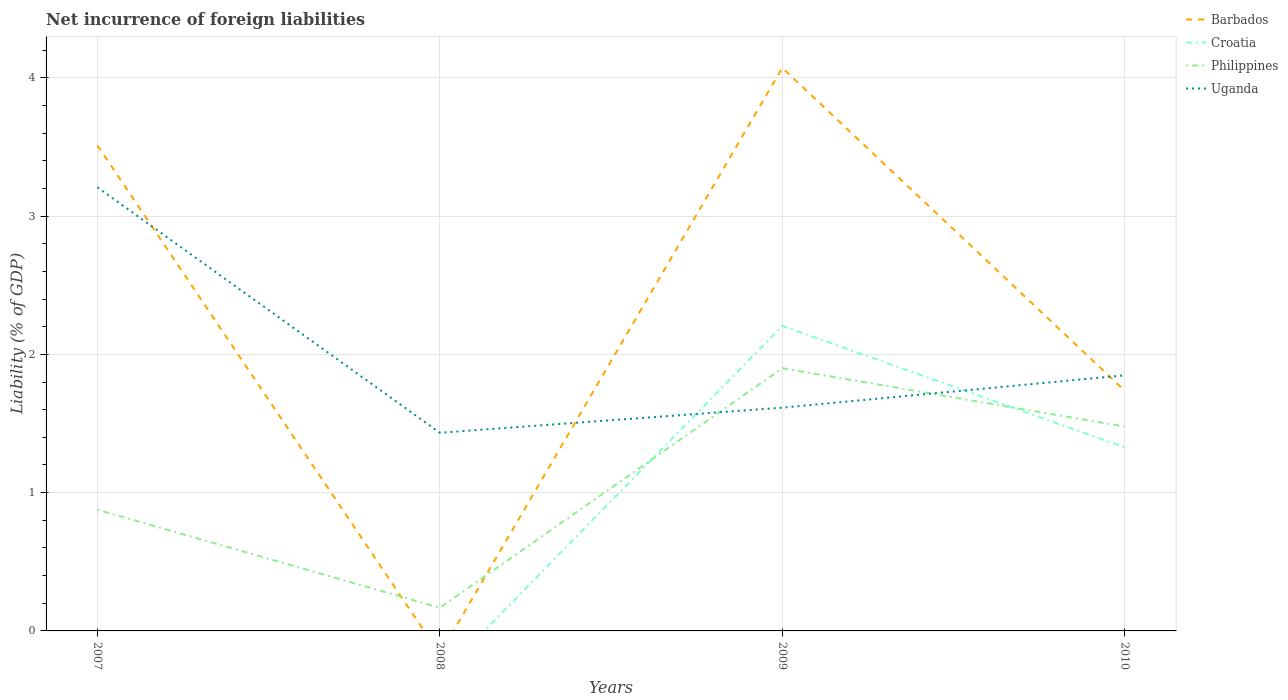How many different coloured lines are there?
Keep it short and to the point. 4. Does the line corresponding to Barbados intersect with the line corresponding to Uganda?
Give a very brief answer. Yes. Is the number of lines equal to the number of legend labels?
Keep it short and to the point. No. Across all years, what is the maximum net incurrence of foreign liabilities in Philippines?
Your answer should be compact. 0.17. What is the total net incurrence of foreign liabilities in Philippines in the graph?
Provide a short and direct response. -0.6. What is the difference between the highest and the second highest net incurrence of foreign liabilities in Uganda?
Keep it short and to the point. 1.78. How many years are there in the graph?
Offer a very short reply. 4. What is the difference between two consecutive major ticks on the Y-axis?
Provide a short and direct response. 1. How many legend labels are there?
Offer a very short reply. 4. What is the title of the graph?
Make the answer very short. Net incurrence of foreign liabilities. What is the label or title of the Y-axis?
Your response must be concise. Liability (% of GDP). What is the Liability (% of GDP) in Barbados in 2007?
Provide a short and direct response. 3.51. What is the Liability (% of GDP) in Croatia in 2007?
Your answer should be compact. 0. What is the Liability (% of GDP) of Philippines in 2007?
Your response must be concise. 0.88. What is the Liability (% of GDP) of Uganda in 2007?
Provide a succinct answer. 3.21. What is the Liability (% of GDP) of Barbados in 2008?
Offer a very short reply. 0. What is the Liability (% of GDP) in Philippines in 2008?
Offer a terse response. 0.17. What is the Liability (% of GDP) of Uganda in 2008?
Ensure brevity in your answer.  1.43. What is the Liability (% of GDP) in Barbados in 2009?
Provide a short and direct response. 4.07. What is the Liability (% of GDP) in Croatia in 2009?
Give a very brief answer. 2.21. What is the Liability (% of GDP) in Philippines in 2009?
Ensure brevity in your answer.  1.9. What is the Liability (% of GDP) of Uganda in 2009?
Your response must be concise. 1.61. What is the Liability (% of GDP) of Barbados in 2010?
Offer a very short reply. 1.74. What is the Liability (% of GDP) of Croatia in 2010?
Your response must be concise. 1.33. What is the Liability (% of GDP) of Philippines in 2010?
Keep it short and to the point. 1.48. What is the Liability (% of GDP) of Uganda in 2010?
Your response must be concise. 1.85. Across all years, what is the maximum Liability (% of GDP) of Barbados?
Make the answer very short. 4.07. Across all years, what is the maximum Liability (% of GDP) in Croatia?
Make the answer very short. 2.21. Across all years, what is the maximum Liability (% of GDP) of Philippines?
Keep it short and to the point. 1.9. Across all years, what is the maximum Liability (% of GDP) in Uganda?
Your answer should be very brief. 3.21. Across all years, what is the minimum Liability (% of GDP) in Barbados?
Ensure brevity in your answer.  0. Across all years, what is the minimum Liability (% of GDP) of Croatia?
Your response must be concise. 0. Across all years, what is the minimum Liability (% of GDP) of Philippines?
Your answer should be very brief. 0.17. Across all years, what is the minimum Liability (% of GDP) of Uganda?
Your answer should be compact. 1.43. What is the total Liability (% of GDP) in Barbados in the graph?
Give a very brief answer. 9.32. What is the total Liability (% of GDP) of Croatia in the graph?
Offer a terse response. 3.53. What is the total Liability (% of GDP) of Philippines in the graph?
Your answer should be compact. 4.42. What is the total Liability (% of GDP) in Uganda in the graph?
Offer a very short reply. 8.1. What is the difference between the Liability (% of GDP) of Philippines in 2007 and that in 2008?
Your answer should be very brief. 0.71. What is the difference between the Liability (% of GDP) in Uganda in 2007 and that in 2008?
Keep it short and to the point. 1.78. What is the difference between the Liability (% of GDP) in Barbados in 2007 and that in 2009?
Keep it short and to the point. -0.56. What is the difference between the Liability (% of GDP) in Philippines in 2007 and that in 2009?
Make the answer very short. -1.02. What is the difference between the Liability (% of GDP) of Uganda in 2007 and that in 2009?
Keep it short and to the point. 1.59. What is the difference between the Liability (% of GDP) in Barbados in 2007 and that in 2010?
Your answer should be very brief. 1.77. What is the difference between the Liability (% of GDP) in Philippines in 2007 and that in 2010?
Provide a short and direct response. -0.6. What is the difference between the Liability (% of GDP) of Uganda in 2007 and that in 2010?
Offer a terse response. 1.36. What is the difference between the Liability (% of GDP) in Philippines in 2008 and that in 2009?
Provide a succinct answer. -1.73. What is the difference between the Liability (% of GDP) of Uganda in 2008 and that in 2009?
Ensure brevity in your answer.  -0.18. What is the difference between the Liability (% of GDP) of Philippines in 2008 and that in 2010?
Offer a terse response. -1.31. What is the difference between the Liability (% of GDP) in Uganda in 2008 and that in 2010?
Provide a short and direct response. -0.42. What is the difference between the Liability (% of GDP) in Barbados in 2009 and that in 2010?
Offer a very short reply. 2.33. What is the difference between the Liability (% of GDP) of Croatia in 2009 and that in 2010?
Your answer should be very brief. 0.88. What is the difference between the Liability (% of GDP) in Philippines in 2009 and that in 2010?
Keep it short and to the point. 0.42. What is the difference between the Liability (% of GDP) in Uganda in 2009 and that in 2010?
Make the answer very short. -0.23. What is the difference between the Liability (% of GDP) in Barbados in 2007 and the Liability (% of GDP) in Philippines in 2008?
Make the answer very short. 3.34. What is the difference between the Liability (% of GDP) in Barbados in 2007 and the Liability (% of GDP) in Uganda in 2008?
Provide a short and direct response. 2.08. What is the difference between the Liability (% of GDP) in Philippines in 2007 and the Liability (% of GDP) in Uganda in 2008?
Ensure brevity in your answer.  -0.56. What is the difference between the Liability (% of GDP) in Barbados in 2007 and the Liability (% of GDP) in Croatia in 2009?
Your response must be concise. 1.31. What is the difference between the Liability (% of GDP) of Barbados in 2007 and the Liability (% of GDP) of Philippines in 2009?
Make the answer very short. 1.61. What is the difference between the Liability (% of GDP) in Barbados in 2007 and the Liability (% of GDP) in Uganda in 2009?
Ensure brevity in your answer.  1.9. What is the difference between the Liability (% of GDP) of Philippines in 2007 and the Liability (% of GDP) of Uganda in 2009?
Ensure brevity in your answer.  -0.74. What is the difference between the Liability (% of GDP) of Barbados in 2007 and the Liability (% of GDP) of Croatia in 2010?
Ensure brevity in your answer.  2.18. What is the difference between the Liability (% of GDP) in Barbados in 2007 and the Liability (% of GDP) in Philippines in 2010?
Ensure brevity in your answer.  2.03. What is the difference between the Liability (% of GDP) in Barbados in 2007 and the Liability (% of GDP) in Uganda in 2010?
Your response must be concise. 1.66. What is the difference between the Liability (% of GDP) in Philippines in 2007 and the Liability (% of GDP) in Uganda in 2010?
Offer a very short reply. -0.97. What is the difference between the Liability (% of GDP) in Philippines in 2008 and the Liability (% of GDP) in Uganda in 2009?
Make the answer very short. -1.45. What is the difference between the Liability (% of GDP) of Philippines in 2008 and the Liability (% of GDP) of Uganda in 2010?
Offer a very short reply. -1.68. What is the difference between the Liability (% of GDP) in Barbados in 2009 and the Liability (% of GDP) in Croatia in 2010?
Provide a short and direct response. 2.74. What is the difference between the Liability (% of GDP) of Barbados in 2009 and the Liability (% of GDP) of Philippines in 2010?
Offer a terse response. 2.59. What is the difference between the Liability (% of GDP) of Barbados in 2009 and the Liability (% of GDP) of Uganda in 2010?
Offer a very short reply. 2.22. What is the difference between the Liability (% of GDP) of Croatia in 2009 and the Liability (% of GDP) of Philippines in 2010?
Provide a succinct answer. 0.73. What is the difference between the Liability (% of GDP) of Croatia in 2009 and the Liability (% of GDP) of Uganda in 2010?
Ensure brevity in your answer.  0.36. What is the difference between the Liability (% of GDP) in Philippines in 2009 and the Liability (% of GDP) in Uganda in 2010?
Keep it short and to the point. 0.05. What is the average Liability (% of GDP) of Barbados per year?
Your answer should be very brief. 2.33. What is the average Liability (% of GDP) of Croatia per year?
Your answer should be compact. 0.88. What is the average Liability (% of GDP) in Philippines per year?
Make the answer very short. 1.11. What is the average Liability (% of GDP) of Uganda per year?
Offer a very short reply. 2.03. In the year 2007, what is the difference between the Liability (% of GDP) in Barbados and Liability (% of GDP) in Philippines?
Keep it short and to the point. 2.63. In the year 2007, what is the difference between the Liability (% of GDP) of Barbados and Liability (% of GDP) of Uganda?
Give a very brief answer. 0.3. In the year 2007, what is the difference between the Liability (% of GDP) of Philippines and Liability (% of GDP) of Uganda?
Offer a very short reply. -2.33. In the year 2008, what is the difference between the Liability (% of GDP) in Philippines and Liability (% of GDP) in Uganda?
Offer a terse response. -1.27. In the year 2009, what is the difference between the Liability (% of GDP) in Barbados and Liability (% of GDP) in Croatia?
Your response must be concise. 1.87. In the year 2009, what is the difference between the Liability (% of GDP) in Barbados and Liability (% of GDP) in Philippines?
Keep it short and to the point. 2.17. In the year 2009, what is the difference between the Liability (% of GDP) in Barbados and Liability (% of GDP) in Uganda?
Offer a very short reply. 2.46. In the year 2009, what is the difference between the Liability (% of GDP) in Croatia and Liability (% of GDP) in Philippines?
Ensure brevity in your answer.  0.31. In the year 2009, what is the difference between the Liability (% of GDP) of Croatia and Liability (% of GDP) of Uganda?
Make the answer very short. 0.59. In the year 2009, what is the difference between the Liability (% of GDP) of Philippines and Liability (% of GDP) of Uganda?
Offer a very short reply. 0.29. In the year 2010, what is the difference between the Liability (% of GDP) in Barbados and Liability (% of GDP) in Croatia?
Ensure brevity in your answer.  0.41. In the year 2010, what is the difference between the Liability (% of GDP) in Barbados and Liability (% of GDP) in Philippines?
Your response must be concise. 0.26. In the year 2010, what is the difference between the Liability (% of GDP) in Barbados and Liability (% of GDP) in Uganda?
Provide a short and direct response. -0.11. In the year 2010, what is the difference between the Liability (% of GDP) of Croatia and Liability (% of GDP) of Philippines?
Make the answer very short. -0.15. In the year 2010, what is the difference between the Liability (% of GDP) of Croatia and Liability (% of GDP) of Uganda?
Your response must be concise. -0.52. In the year 2010, what is the difference between the Liability (% of GDP) of Philippines and Liability (% of GDP) of Uganda?
Keep it short and to the point. -0.37. What is the ratio of the Liability (% of GDP) of Philippines in 2007 to that in 2008?
Offer a very short reply. 5.24. What is the ratio of the Liability (% of GDP) in Uganda in 2007 to that in 2008?
Your response must be concise. 2.24. What is the ratio of the Liability (% of GDP) of Barbados in 2007 to that in 2009?
Offer a terse response. 0.86. What is the ratio of the Liability (% of GDP) in Philippines in 2007 to that in 2009?
Your response must be concise. 0.46. What is the ratio of the Liability (% of GDP) in Uganda in 2007 to that in 2009?
Provide a succinct answer. 1.99. What is the ratio of the Liability (% of GDP) of Barbados in 2007 to that in 2010?
Give a very brief answer. 2.02. What is the ratio of the Liability (% of GDP) of Philippines in 2007 to that in 2010?
Provide a short and direct response. 0.59. What is the ratio of the Liability (% of GDP) of Uganda in 2007 to that in 2010?
Offer a very short reply. 1.74. What is the ratio of the Liability (% of GDP) of Philippines in 2008 to that in 2009?
Give a very brief answer. 0.09. What is the ratio of the Liability (% of GDP) in Uganda in 2008 to that in 2009?
Make the answer very short. 0.89. What is the ratio of the Liability (% of GDP) in Philippines in 2008 to that in 2010?
Your answer should be compact. 0.11. What is the ratio of the Liability (% of GDP) in Uganda in 2008 to that in 2010?
Your answer should be very brief. 0.78. What is the ratio of the Liability (% of GDP) in Barbados in 2009 to that in 2010?
Keep it short and to the point. 2.34. What is the ratio of the Liability (% of GDP) of Croatia in 2009 to that in 2010?
Your answer should be very brief. 1.66. What is the ratio of the Liability (% of GDP) of Philippines in 2009 to that in 2010?
Provide a short and direct response. 1.29. What is the ratio of the Liability (% of GDP) of Uganda in 2009 to that in 2010?
Offer a very short reply. 0.87. What is the difference between the highest and the second highest Liability (% of GDP) in Barbados?
Your answer should be very brief. 0.56. What is the difference between the highest and the second highest Liability (% of GDP) in Philippines?
Keep it short and to the point. 0.42. What is the difference between the highest and the second highest Liability (% of GDP) of Uganda?
Offer a very short reply. 1.36. What is the difference between the highest and the lowest Liability (% of GDP) of Barbados?
Your response must be concise. 4.07. What is the difference between the highest and the lowest Liability (% of GDP) of Croatia?
Offer a very short reply. 2.21. What is the difference between the highest and the lowest Liability (% of GDP) of Philippines?
Make the answer very short. 1.73. What is the difference between the highest and the lowest Liability (% of GDP) in Uganda?
Keep it short and to the point. 1.78. 